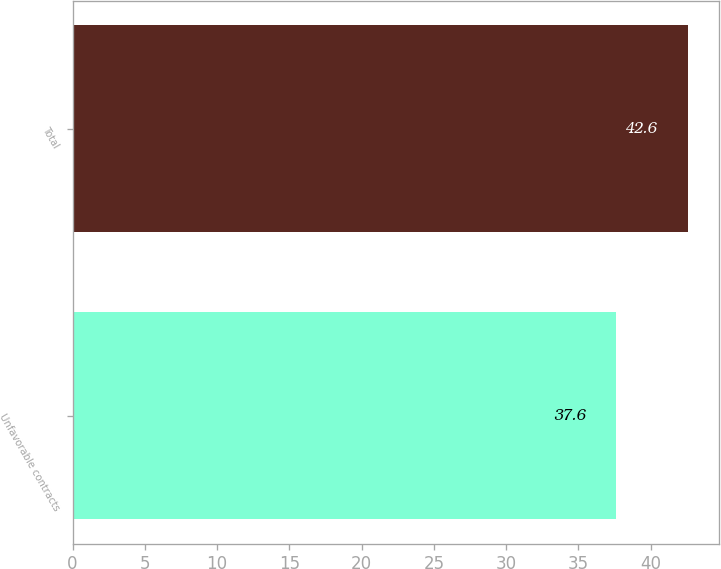Convert chart. <chart><loc_0><loc_0><loc_500><loc_500><bar_chart><fcel>Unfavorable contracts<fcel>Total<nl><fcel>37.6<fcel>42.6<nl></chart> 